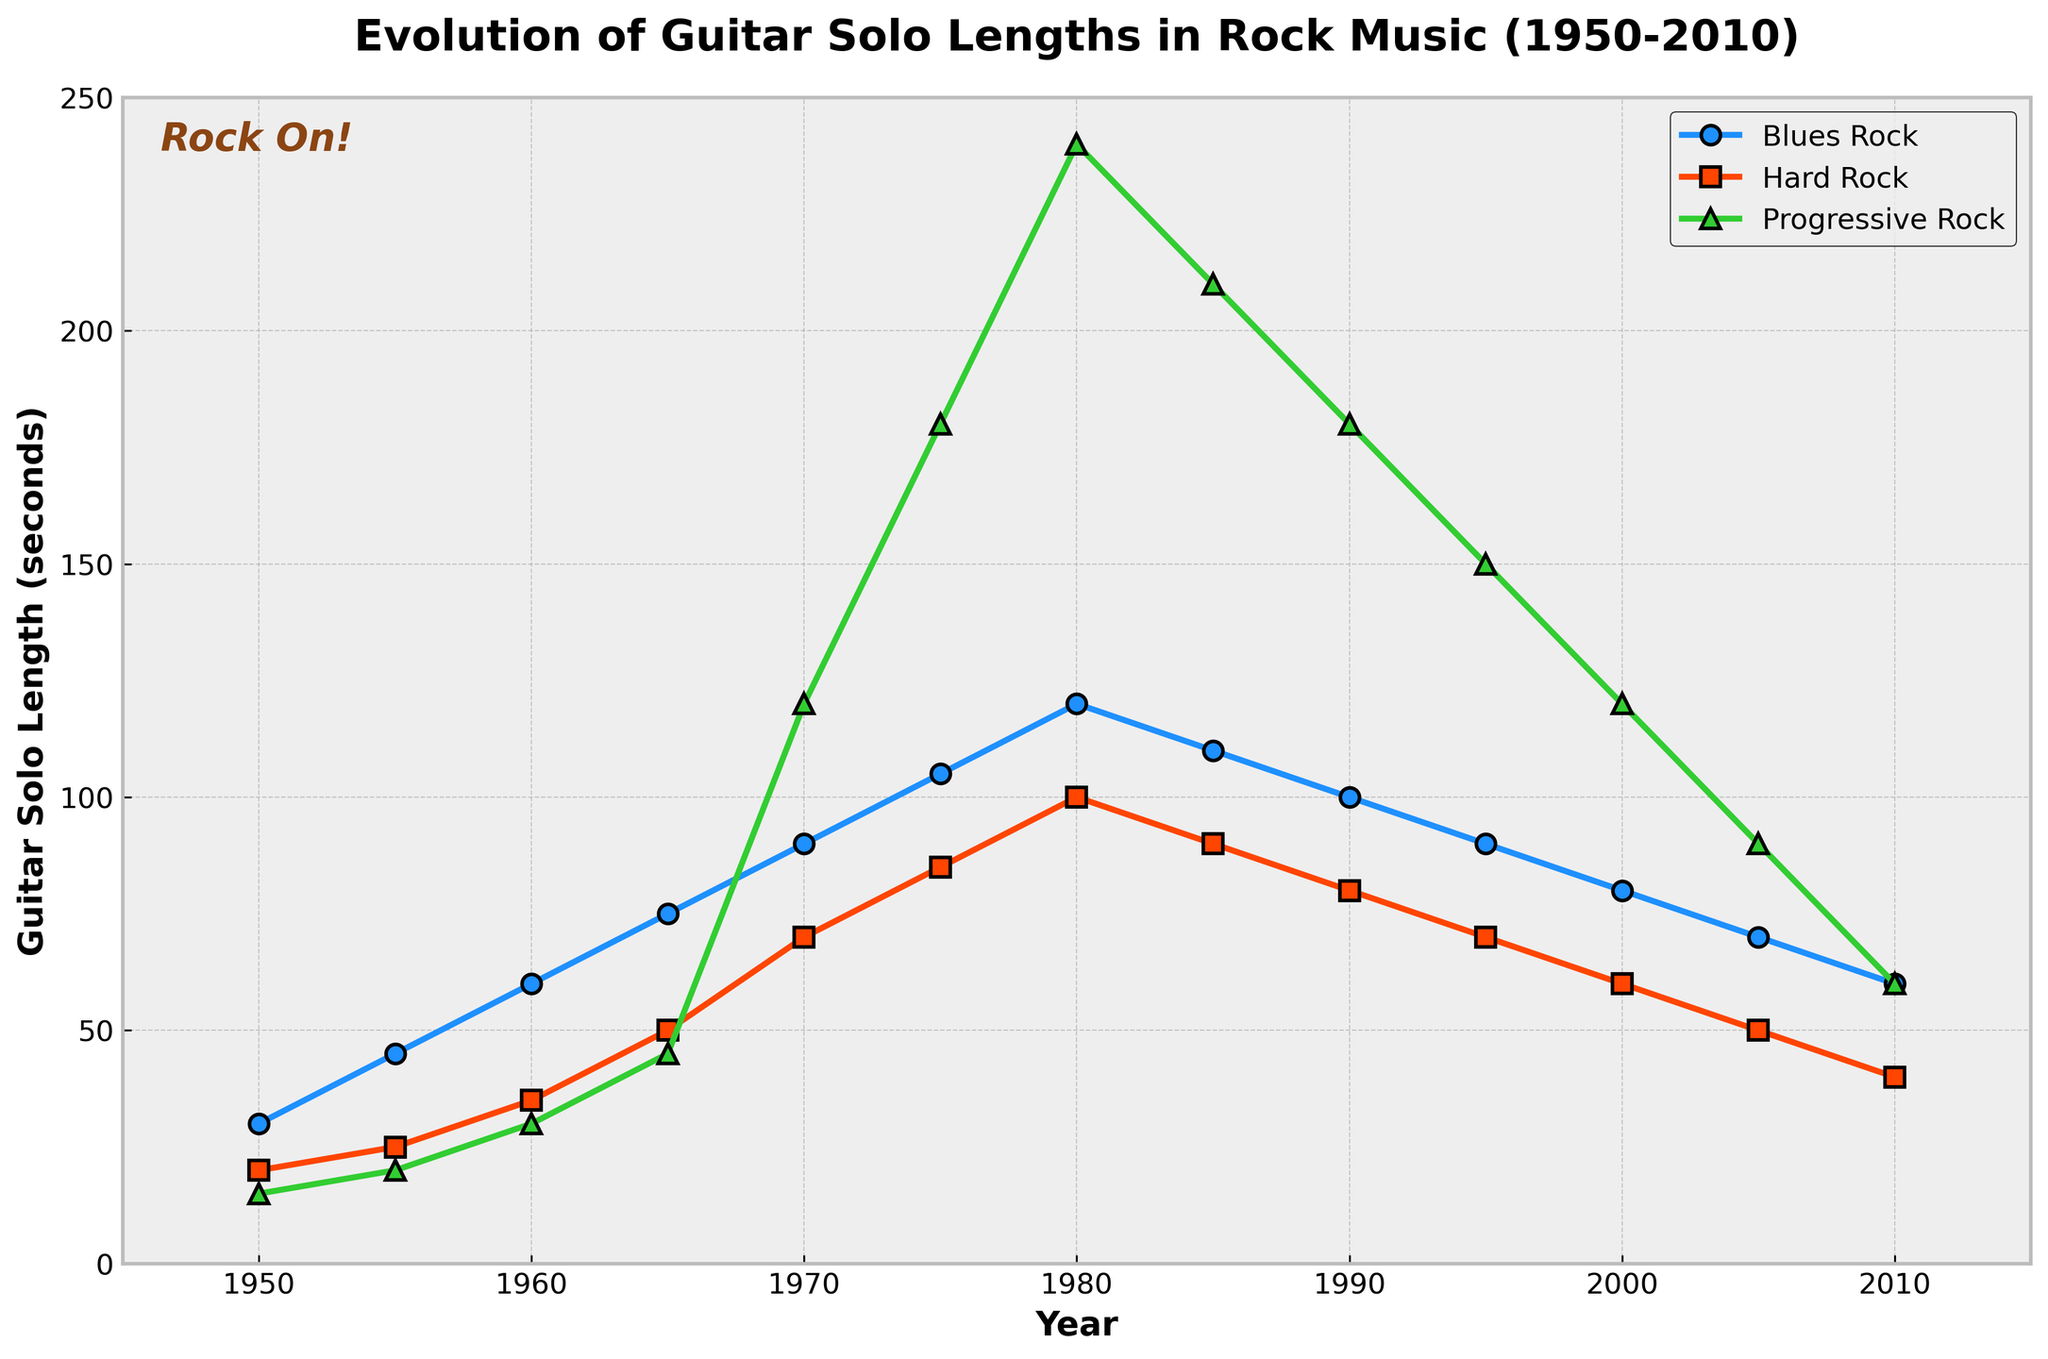Which subgenre had the longest average guitar solo length over the given period (1950-2010)? To find the average guitar solo length for each subgenre over the given period, sum the solo lengths for each subgenre across all years and then divide by the number of years (13). For Blues Rock: (30+45+60+75+90+105+120+110+100+90+80+70+60)/13 = 84.6. For Hard Rock: (20+25+35+50+70+85+100+90+80+70+60+50+40)/13 = 60. For Progressive Rock: (15+20+30+45+120+180+240+210+180+150+120+90+60)/13 = 117.7. Therefore, Progressive Rock had the longest average solo length.
Answer: Progressive Rock Which subgenre showed the steepest increase in guitar solo length from 1950 to 1980? To determine the steepest increase, we need to find the change in solo length from 1950 to 1980 for each subgenre and compare them. For Blues Rock, the increase is 120 - 30 = 90 seconds. For Hard Rock, it is 100 - 20 = 80 seconds. For Progressive Rock, it is 240 - 15 = 225 seconds. Therefore, Progressive Rock showed the steepest increase.
Answer: Progressive Rock What year did Blues Rock reach its peak guitar solo length? Referencing the graph, identify the year where the Blues Rock line reaches its highest point. The highest point for Blues Rock occurs in 1980 at 120 seconds.
Answer: 1980 By how much did the guitar solo length for Progressive Rock decrease between 1980 and 2010? To find the decrease, subtract the 2010 value from the 1980 value for Progressive Rock. That is, 240 - 60 = 180 seconds.
Answer: 180 seconds How did the trend of guitar solo lengths for Hard Rock change after 1980? From 1980 to 2010, the trend in Hard Rock guitar solos shows a decrease. The solo lengths drop from 100 seconds in 1980 to 40 seconds in 2010.
Answer: Decreasing Which year marked the start of a consistent downward trend in guitar solo lengths across all subgenres? By examining the graph, the year when all subgenres show a consistent downward trend is 1980 onwards.
Answer: 1980 Compare the change in guitar solo lengths between 1965 and 1975 for Blues Rock and Hard Rock. Which subgenre exhibited a greater change and by how much? For Blues Rock, the change from 1965 to 1975 is 105 - 75 = 30 seconds. For Hard Rock, the change from 1965 to 1975 is 85 - 50 = 35 seconds. Hard Rock exhibited a greater change by 35 - 30 = 5 seconds.
Answer: Hard Rock, by 5 seconds What visual element on the chart helps distinguish the different subgenres? Each subgenre has a unique color and marker shape, which helps distinguish them: Blues Rock (blue, circle), Hard Rock (red, square), and Progressive Rock (green, triangle).
Answer: Color and marker shape In which decade did Progressive Rock reach its maximum guitar solo length, and what was the length? Looking at the graph, Progressive Rock reached its maximum guitar solo length in the 1980s with a length of 240 seconds.
Answer: 1980s, 240 seconds 